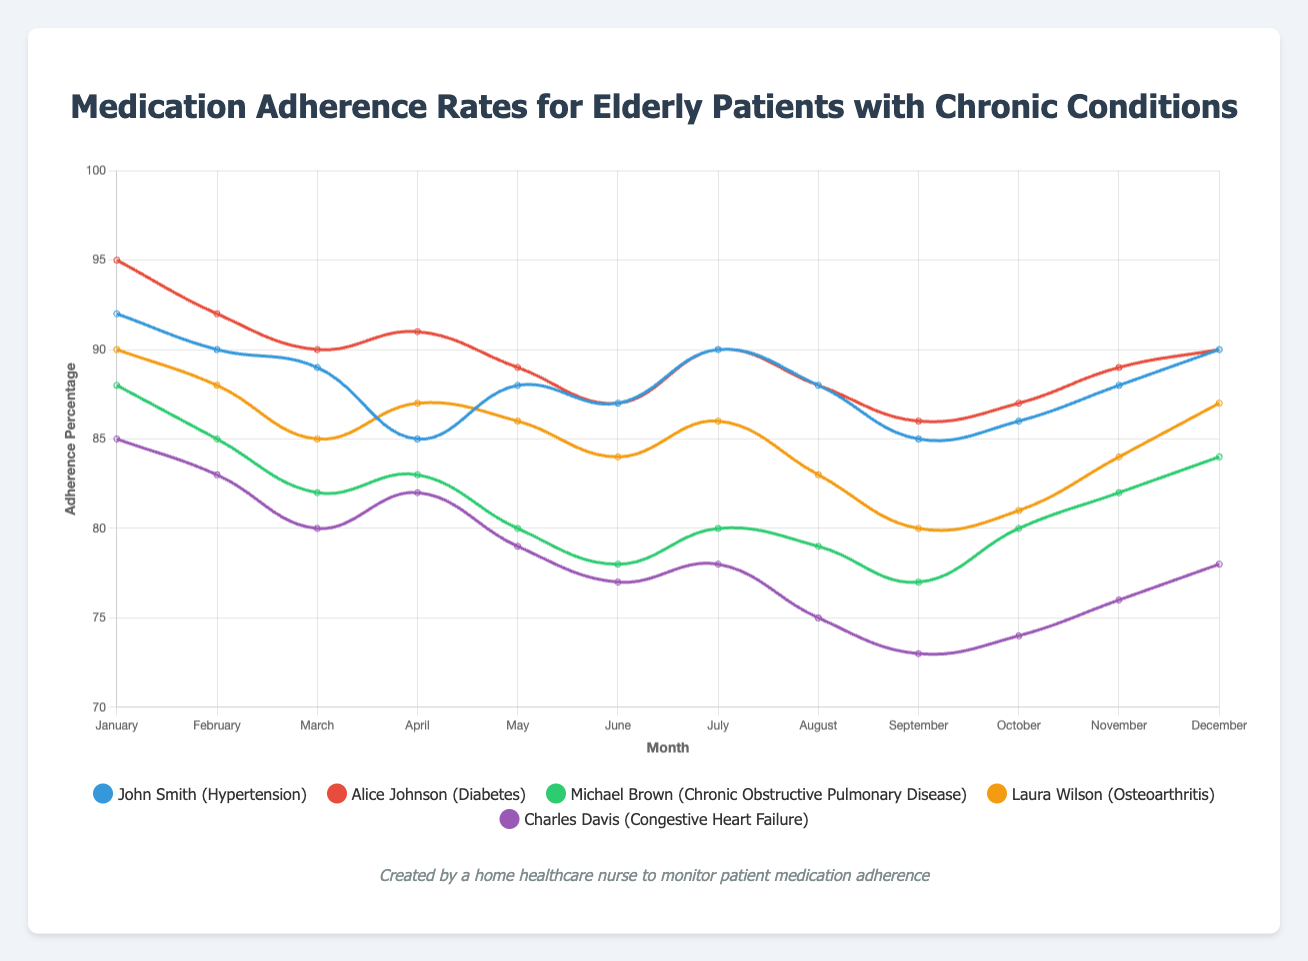Which patient has the most stable adherence rate over the year? To determine the most stable adherence rate, observe the lines representing each patient. The line with the least fluctuations indicates the most stable adherence rate. Alice Johnson's adherence rate varies the least throughout the months.
Answer: Alice Johnson Who had the highest adherence rate in January and what was the percentage? To find this, look at the start of each line at the "January" data point. The highest point belongs to Alice Johnson with a 95% adherence rate.
Answer: Alice Johnson, 95% Compare the adherence rates of John Smith and Laura Wilson in April. Who adhered more, and by what percentage? Find the data points for John Smith and Laura Wilson in April. John Smith had 85%, while Laura Wilson had 87%. Subtract John Smith's adherence from Laura Wilson's.
Answer: Laura Wilson adhered more by 2% Was there any point where Charles Davis and Michael Brown had the same adherence percentage? By examining the graph, check if any two data points for Charles Davis and Michael Brown coincide. They both had 78% adherence in June.
Answer: Yes, in June What is the average adherence rate for Michael Brown in the first quarter (January to March)? Sum the adherence percentages for Michael Brown in January (88%), February (85%), and March (82%), then divide by the number of months (3). (88+85+82)/3 = 85
Answer: 85 Which month had the highest total adherence among all patients combined? Calculate the sum of adherence percentages for all patients for each month and identify the month with the highest total. January has the highest combined total of 450%.
Answer: January What was the range of medication adherence for Laura Wilson over the year? Find the maximum (90% in January) and minimum (80% in September) adherence rates for Laura Wilson. The range is the difference between these two values. (90-80)=10%
Answer: 10% How does the adherence trend of John Smith in the first half of the year compare to the second half? Look at John Smith's adherence percentages for January-June and July-December. See if the second half is overall higher, lower, or consistent compared to the first half. The first half starts high and dips by June (92% to 87%), then slightly rises again toward year-end (90% by December).
Answer: Slight initial decrease, then slight recovery In which month did Alice Johnson have her lowest adherence rate, and what was it? Check the lowest point in Alice Johnson's adherence line. The lowest adherence rate was 86% in September.
Answer: September, 86% What is the total decrease in adherence percentage for Charles Davis from January to September? Subtract the adherence percentage in September from that in January for Charles Davis (85% - 73%).
Answer: 12% 